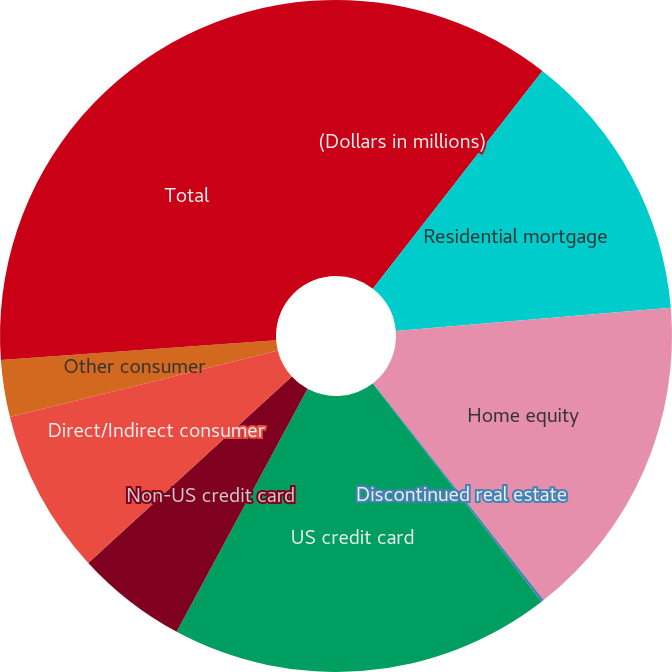Convert chart. <chart><loc_0><loc_0><loc_500><loc_500><pie_chart><fcel>(Dollars in millions)<fcel>Residential mortgage<fcel>Home equity<fcel>Discontinued real estate<fcel>US credit card<fcel>Non-US credit card<fcel>Direct/Indirect consumer<fcel>Other consumer<fcel>Total<nl><fcel>10.53%<fcel>13.13%<fcel>15.73%<fcel>0.13%<fcel>18.34%<fcel>5.33%<fcel>7.93%<fcel>2.73%<fcel>26.14%<nl></chart> 